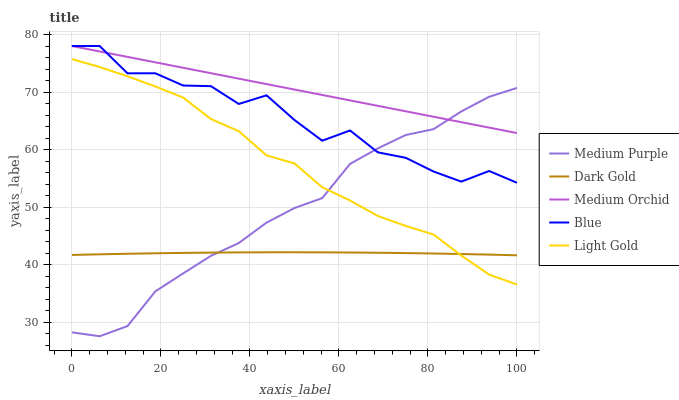Does Dark Gold have the minimum area under the curve?
Answer yes or no. Yes. Does Medium Orchid have the maximum area under the curve?
Answer yes or no. Yes. Does Blue have the minimum area under the curve?
Answer yes or no. No. Does Blue have the maximum area under the curve?
Answer yes or no. No. Is Medium Orchid the smoothest?
Answer yes or no. Yes. Is Blue the roughest?
Answer yes or no. Yes. Is Blue the smoothest?
Answer yes or no. No. Is Medium Orchid the roughest?
Answer yes or no. No. Does Blue have the lowest value?
Answer yes or no. No. Does Light Gold have the highest value?
Answer yes or no. No. Is Light Gold less than Medium Orchid?
Answer yes or no. Yes. Is Blue greater than Light Gold?
Answer yes or no. Yes. Does Light Gold intersect Medium Orchid?
Answer yes or no. No. 